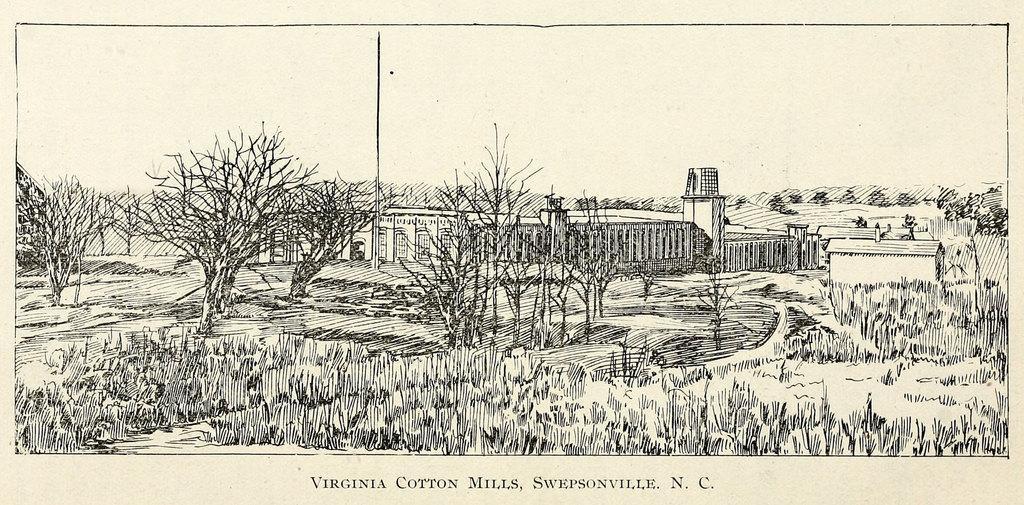Please provide a concise description of this image. This image consists of a poster. In which there is a drawing of a building along trees and grass. 